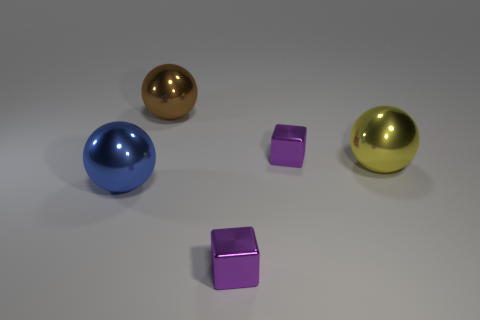Is the number of purple matte objects less than the number of brown balls?
Keep it short and to the point. Yes. Is there a blue metal thing right of the large yellow sphere behind the shiny thing that is to the left of the big brown shiny thing?
Your answer should be compact. No. There is a small metallic thing that is behind the blue metal ball; is its shape the same as the big brown thing?
Your answer should be compact. No. Is the number of yellow balls that are left of the big blue thing greater than the number of green rubber cylinders?
Offer a very short reply. No. What color is the big metal ball to the right of the shiny block right of the purple thing in front of the big blue metal ball?
Make the answer very short. Yellow. Is the size of the brown object the same as the blue thing?
Your answer should be compact. Yes. How many metal objects have the same size as the blue metallic ball?
Provide a succinct answer. 2. Does the large brown thing behind the yellow thing have the same material as the yellow object that is in front of the large brown sphere?
Ensure brevity in your answer.  Yes. Is there anything else that has the same shape as the blue metallic object?
Your response must be concise. Yes. How many purple shiny things are the same shape as the large blue thing?
Provide a short and direct response. 0. 